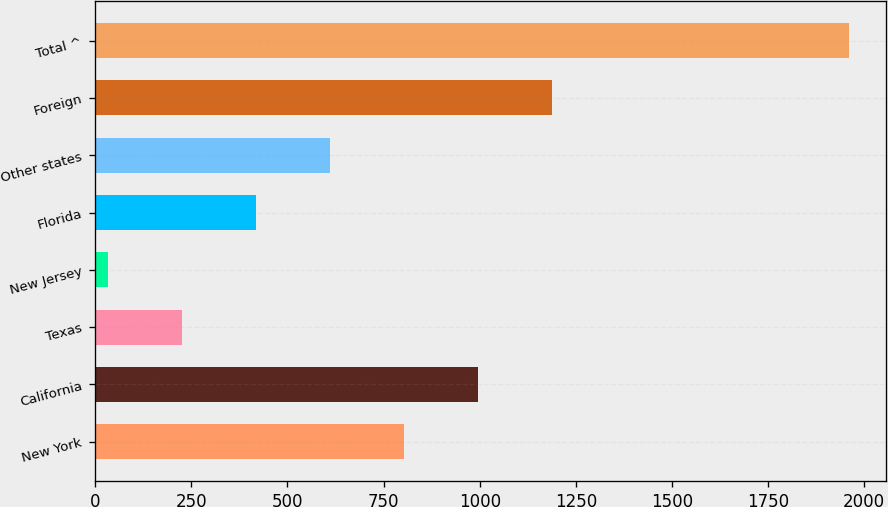Convert chart. <chart><loc_0><loc_0><loc_500><loc_500><bar_chart><fcel>New York<fcel>California<fcel>Texas<fcel>New Jersey<fcel>Florida<fcel>Other states<fcel>Foreign<fcel>Total ^<nl><fcel>803.2<fcel>996<fcel>224.8<fcel>32<fcel>417.6<fcel>610.4<fcel>1188.8<fcel>1960<nl></chart> 